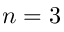<formula> <loc_0><loc_0><loc_500><loc_500>n = 3</formula> 